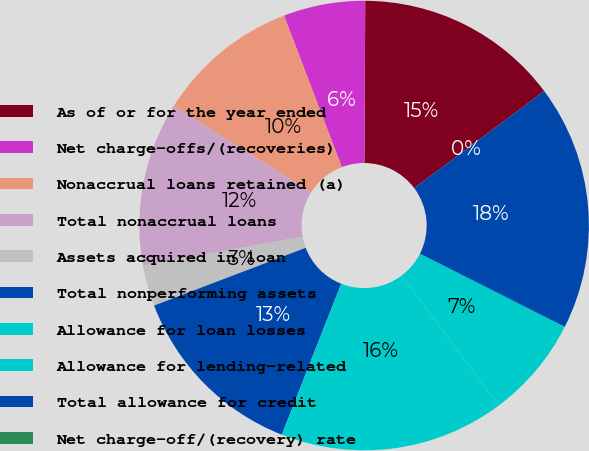Convert chart. <chart><loc_0><loc_0><loc_500><loc_500><pie_chart><fcel>As of or for the year ended<fcel>Net charge-offs/(recoveries)<fcel>Nonaccrual loans retained (a)<fcel>Total nonaccrual loans<fcel>Assets acquired in loan<fcel>Total nonperforming assets<fcel>Allowance for loan losses<fcel>Allowance for lending-related<fcel>Total allowance for credit<fcel>Net charge-off/(recovery) rate<nl><fcel>14.71%<fcel>5.88%<fcel>10.29%<fcel>11.76%<fcel>2.94%<fcel>13.24%<fcel>16.18%<fcel>7.35%<fcel>17.65%<fcel>0.0%<nl></chart> 